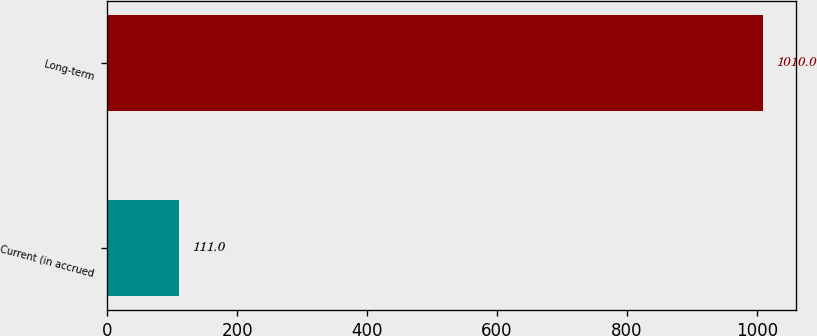Convert chart. <chart><loc_0><loc_0><loc_500><loc_500><bar_chart><fcel>Current (in accrued<fcel>Long-term<nl><fcel>111<fcel>1010<nl></chart> 